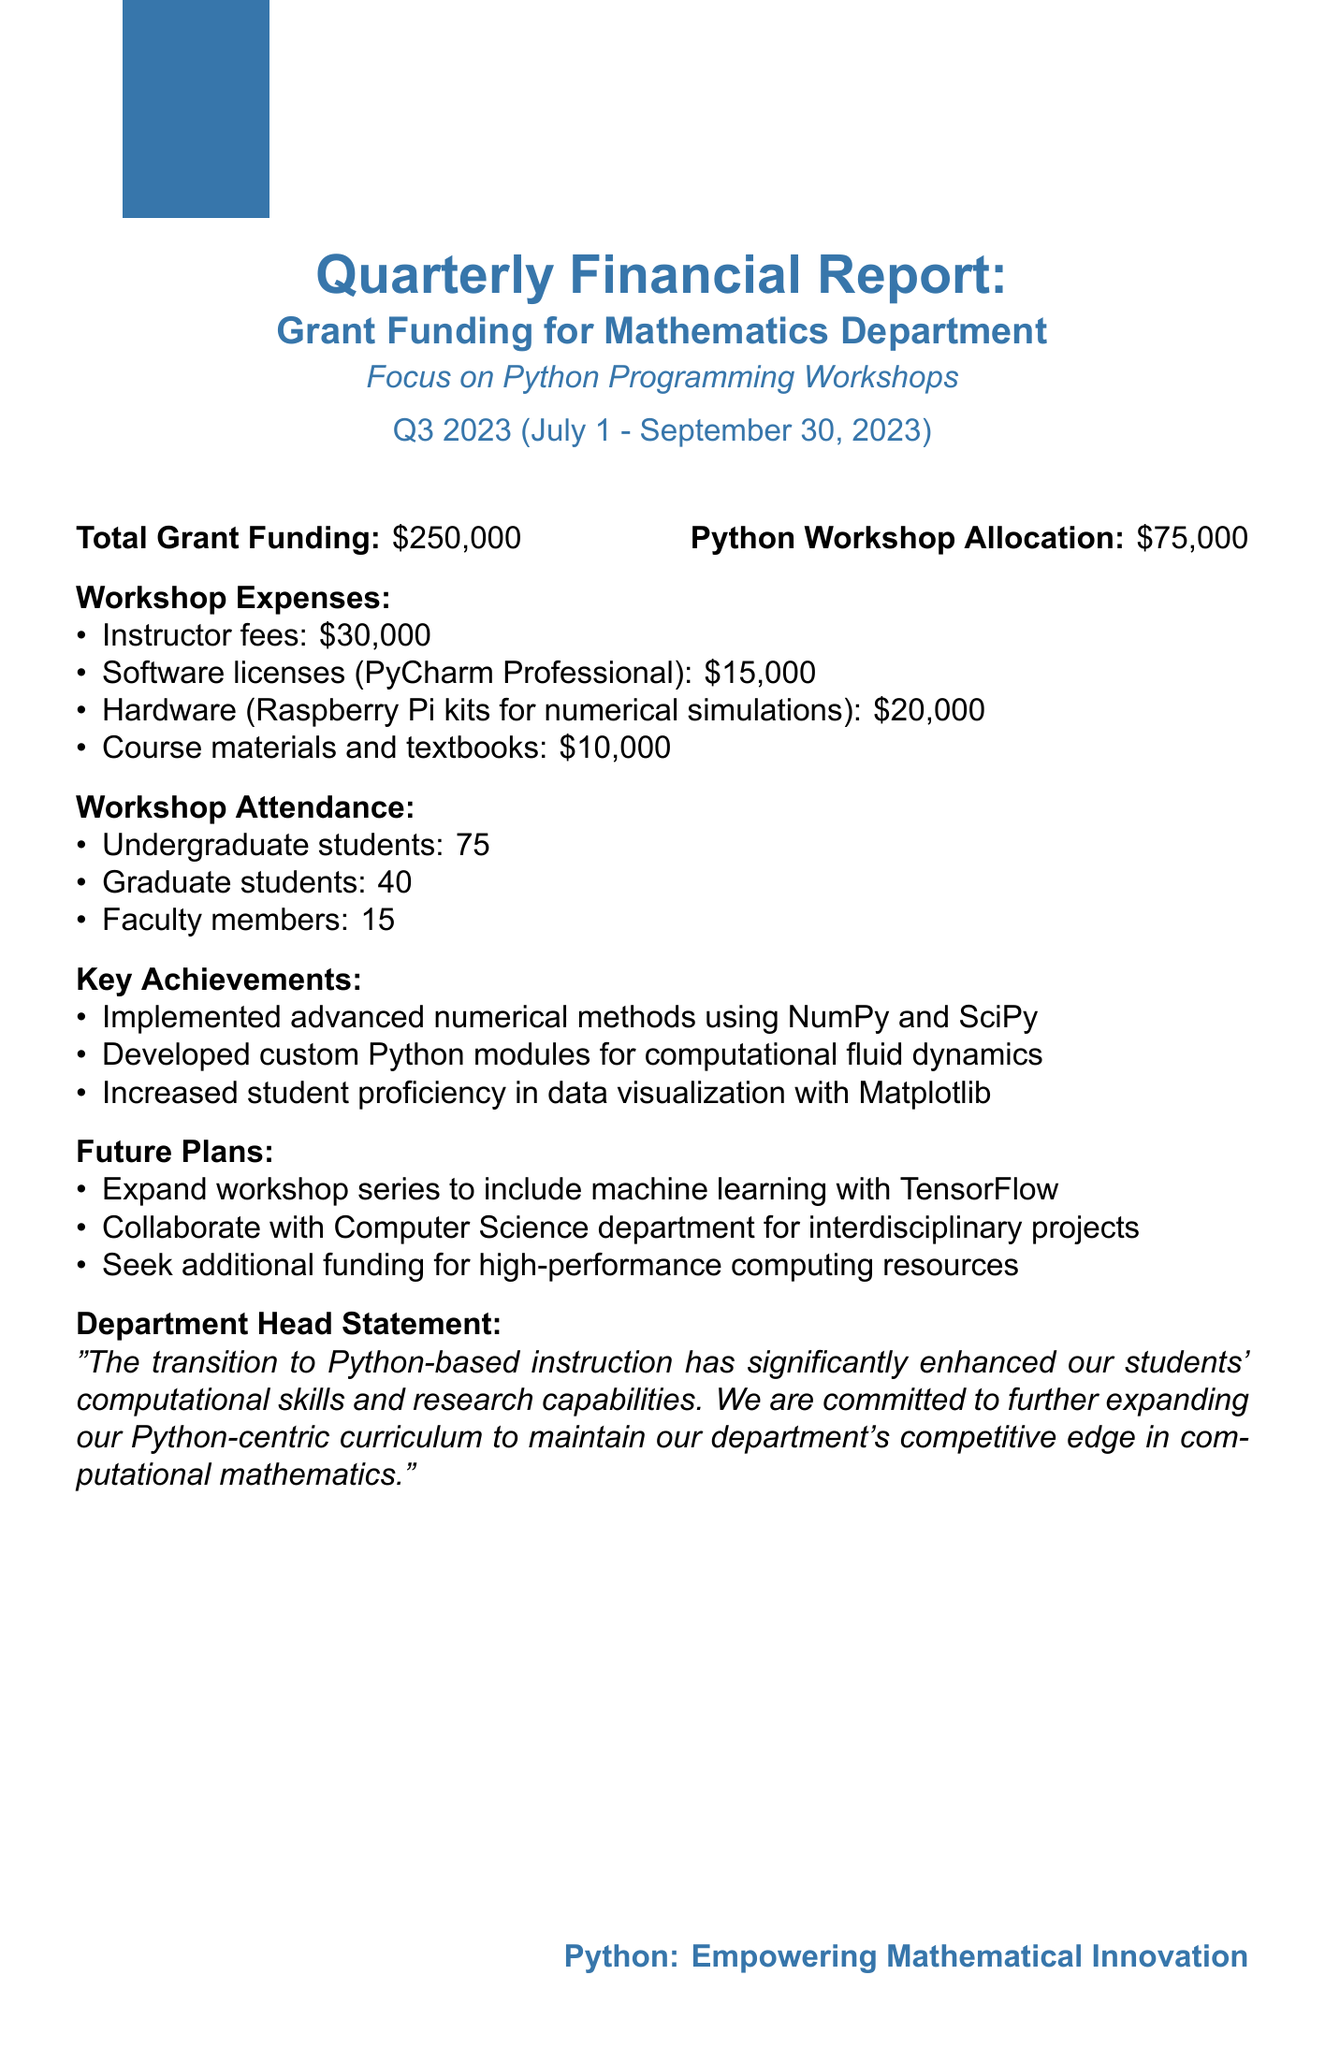What is the total grant funding? The total grant funding is stated as the overall amount allocated to the department, which is $250,000.
Answer: $250,000 How much was allocated for Python workshops? The amount specifically set aside for Python programming workshops is provided in the report.
Answer: $75,000 What was the expense for instructor fees? The document lists the instructor fees as part of the workshop expenses.
Answer: $30,000 How many undergraduate students attended the workshop? The workshop attendance section specifies the number of undergraduate students who participated.
Answer: 75 What are the key achievements mentioned in the report? The report highlights multiple achievements related to Python programming and its impact on students' skills.
Answer: Implemented advanced numerical methods using NumPy and SciPy What future plan involves collaboration? The future plans list includes a specific collaboration effort with another department.
Answer: Collaborate with Computer Science department for interdisciplinary projects What programming tools were included in the workshop expenses? The workshop expenses include various software and hardware tools related to the Python programming curriculum.
Answer: Software licenses (PyCharm Professional) How many graduate students attended the workshop? The report provides the number of graduate students who participated in the workshops.
Answer: 40 What is the department head's statement about the transition to Python? The department head's statement reflects the positive impact of Python-based instruction.
Answer: The transition to Python-based instruction has significantly enhanced our students' computational skills and research capabilities 